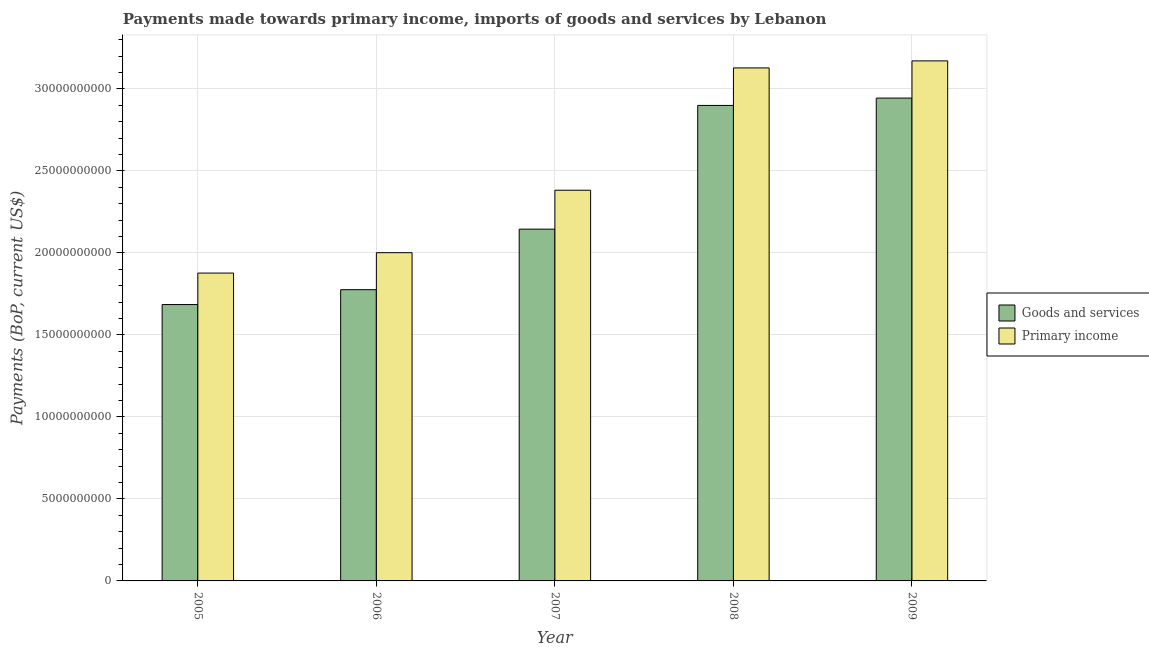Are the number of bars on each tick of the X-axis equal?
Give a very brief answer. Yes. How many bars are there on the 4th tick from the left?
Your answer should be very brief. 2. How many bars are there on the 5th tick from the right?
Provide a short and direct response. 2. What is the payments made towards primary income in 2009?
Your response must be concise. 3.17e+1. Across all years, what is the maximum payments made towards primary income?
Your response must be concise. 3.17e+1. Across all years, what is the minimum payments made towards goods and services?
Your answer should be compact. 1.68e+1. In which year was the payments made towards goods and services maximum?
Give a very brief answer. 2009. What is the total payments made towards primary income in the graph?
Ensure brevity in your answer.  1.26e+11. What is the difference between the payments made towards goods and services in 2006 and that in 2009?
Provide a short and direct response. -1.17e+1. What is the difference between the payments made towards primary income in 2009 and the payments made towards goods and services in 2008?
Provide a succinct answer. 4.30e+08. What is the average payments made towards primary income per year?
Keep it short and to the point. 2.51e+1. In the year 2005, what is the difference between the payments made towards primary income and payments made towards goods and services?
Give a very brief answer. 0. In how many years, is the payments made towards primary income greater than 6000000000 US$?
Offer a terse response. 5. What is the ratio of the payments made towards primary income in 2005 to that in 2007?
Provide a succinct answer. 0.79. Is the difference between the payments made towards goods and services in 2006 and 2009 greater than the difference between the payments made towards primary income in 2006 and 2009?
Keep it short and to the point. No. What is the difference between the highest and the second highest payments made towards goods and services?
Your response must be concise. 4.48e+08. What is the difference between the highest and the lowest payments made towards primary income?
Keep it short and to the point. 1.29e+1. In how many years, is the payments made towards primary income greater than the average payments made towards primary income taken over all years?
Your answer should be compact. 2. What does the 2nd bar from the left in 2005 represents?
Provide a succinct answer. Primary income. What does the 1st bar from the right in 2007 represents?
Give a very brief answer. Primary income. How many bars are there?
Give a very brief answer. 10. How many years are there in the graph?
Provide a short and direct response. 5. Are the values on the major ticks of Y-axis written in scientific E-notation?
Offer a very short reply. No. Does the graph contain any zero values?
Keep it short and to the point. No. Does the graph contain grids?
Make the answer very short. Yes. Where does the legend appear in the graph?
Give a very brief answer. Center right. What is the title of the graph?
Offer a very short reply. Payments made towards primary income, imports of goods and services by Lebanon. What is the label or title of the Y-axis?
Ensure brevity in your answer.  Payments (BoP, current US$). What is the Payments (BoP, current US$) in Goods and services in 2005?
Ensure brevity in your answer.  1.68e+1. What is the Payments (BoP, current US$) of Primary income in 2005?
Keep it short and to the point. 1.88e+1. What is the Payments (BoP, current US$) in Goods and services in 2006?
Offer a very short reply. 1.78e+1. What is the Payments (BoP, current US$) in Primary income in 2006?
Keep it short and to the point. 2.00e+1. What is the Payments (BoP, current US$) of Goods and services in 2007?
Ensure brevity in your answer.  2.14e+1. What is the Payments (BoP, current US$) in Primary income in 2007?
Your response must be concise. 2.38e+1. What is the Payments (BoP, current US$) of Goods and services in 2008?
Your response must be concise. 2.90e+1. What is the Payments (BoP, current US$) of Primary income in 2008?
Offer a very short reply. 3.13e+1. What is the Payments (BoP, current US$) in Goods and services in 2009?
Keep it short and to the point. 2.94e+1. What is the Payments (BoP, current US$) of Primary income in 2009?
Provide a succinct answer. 3.17e+1. Across all years, what is the maximum Payments (BoP, current US$) in Goods and services?
Your answer should be compact. 2.94e+1. Across all years, what is the maximum Payments (BoP, current US$) of Primary income?
Provide a succinct answer. 3.17e+1. Across all years, what is the minimum Payments (BoP, current US$) of Goods and services?
Offer a very short reply. 1.68e+1. Across all years, what is the minimum Payments (BoP, current US$) of Primary income?
Provide a short and direct response. 1.88e+1. What is the total Payments (BoP, current US$) in Goods and services in the graph?
Provide a succinct answer. 1.14e+11. What is the total Payments (BoP, current US$) of Primary income in the graph?
Keep it short and to the point. 1.26e+11. What is the difference between the Payments (BoP, current US$) of Goods and services in 2005 and that in 2006?
Give a very brief answer. -9.06e+08. What is the difference between the Payments (BoP, current US$) in Primary income in 2005 and that in 2006?
Keep it short and to the point. -1.24e+09. What is the difference between the Payments (BoP, current US$) of Goods and services in 2005 and that in 2007?
Make the answer very short. -4.60e+09. What is the difference between the Payments (BoP, current US$) in Primary income in 2005 and that in 2007?
Keep it short and to the point. -5.05e+09. What is the difference between the Payments (BoP, current US$) of Goods and services in 2005 and that in 2008?
Make the answer very short. -1.21e+1. What is the difference between the Payments (BoP, current US$) of Primary income in 2005 and that in 2008?
Make the answer very short. -1.25e+1. What is the difference between the Payments (BoP, current US$) in Goods and services in 2005 and that in 2009?
Your answer should be very brief. -1.26e+1. What is the difference between the Payments (BoP, current US$) in Primary income in 2005 and that in 2009?
Make the answer very short. -1.29e+1. What is the difference between the Payments (BoP, current US$) of Goods and services in 2006 and that in 2007?
Your answer should be compact. -3.69e+09. What is the difference between the Payments (BoP, current US$) of Primary income in 2006 and that in 2007?
Provide a short and direct response. -3.81e+09. What is the difference between the Payments (BoP, current US$) in Goods and services in 2006 and that in 2008?
Provide a short and direct response. -1.12e+1. What is the difference between the Payments (BoP, current US$) of Primary income in 2006 and that in 2008?
Make the answer very short. -1.13e+1. What is the difference between the Payments (BoP, current US$) in Goods and services in 2006 and that in 2009?
Provide a short and direct response. -1.17e+1. What is the difference between the Payments (BoP, current US$) of Primary income in 2006 and that in 2009?
Your answer should be compact. -1.17e+1. What is the difference between the Payments (BoP, current US$) of Goods and services in 2007 and that in 2008?
Make the answer very short. -7.54e+09. What is the difference between the Payments (BoP, current US$) in Primary income in 2007 and that in 2008?
Give a very brief answer. -7.46e+09. What is the difference between the Payments (BoP, current US$) of Goods and services in 2007 and that in 2009?
Provide a short and direct response. -7.99e+09. What is the difference between the Payments (BoP, current US$) of Primary income in 2007 and that in 2009?
Provide a short and direct response. -7.89e+09. What is the difference between the Payments (BoP, current US$) in Goods and services in 2008 and that in 2009?
Provide a succinct answer. -4.48e+08. What is the difference between the Payments (BoP, current US$) of Primary income in 2008 and that in 2009?
Your answer should be compact. -4.30e+08. What is the difference between the Payments (BoP, current US$) of Goods and services in 2005 and the Payments (BoP, current US$) of Primary income in 2006?
Keep it short and to the point. -3.16e+09. What is the difference between the Payments (BoP, current US$) in Goods and services in 2005 and the Payments (BoP, current US$) in Primary income in 2007?
Your answer should be compact. -6.97e+09. What is the difference between the Payments (BoP, current US$) in Goods and services in 2005 and the Payments (BoP, current US$) in Primary income in 2008?
Give a very brief answer. -1.44e+1. What is the difference between the Payments (BoP, current US$) of Goods and services in 2005 and the Payments (BoP, current US$) of Primary income in 2009?
Provide a short and direct response. -1.49e+1. What is the difference between the Payments (BoP, current US$) of Goods and services in 2006 and the Payments (BoP, current US$) of Primary income in 2007?
Your answer should be compact. -6.06e+09. What is the difference between the Payments (BoP, current US$) of Goods and services in 2006 and the Payments (BoP, current US$) of Primary income in 2008?
Give a very brief answer. -1.35e+1. What is the difference between the Payments (BoP, current US$) of Goods and services in 2006 and the Payments (BoP, current US$) of Primary income in 2009?
Offer a very short reply. -1.39e+1. What is the difference between the Payments (BoP, current US$) in Goods and services in 2007 and the Payments (BoP, current US$) in Primary income in 2008?
Keep it short and to the point. -9.83e+09. What is the difference between the Payments (BoP, current US$) of Goods and services in 2007 and the Payments (BoP, current US$) of Primary income in 2009?
Your answer should be very brief. -1.03e+1. What is the difference between the Payments (BoP, current US$) in Goods and services in 2008 and the Payments (BoP, current US$) in Primary income in 2009?
Offer a very short reply. -2.72e+09. What is the average Payments (BoP, current US$) in Goods and services per year?
Give a very brief answer. 2.29e+1. What is the average Payments (BoP, current US$) of Primary income per year?
Your answer should be very brief. 2.51e+1. In the year 2005, what is the difference between the Payments (BoP, current US$) in Goods and services and Payments (BoP, current US$) in Primary income?
Give a very brief answer. -1.92e+09. In the year 2006, what is the difference between the Payments (BoP, current US$) in Goods and services and Payments (BoP, current US$) in Primary income?
Your response must be concise. -2.26e+09. In the year 2007, what is the difference between the Payments (BoP, current US$) in Goods and services and Payments (BoP, current US$) in Primary income?
Your answer should be very brief. -2.37e+09. In the year 2008, what is the difference between the Payments (BoP, current US$) in Goods and services and Payments (BoP, current US$) in Primary income?
Offer a terse response. -2.29e+09. In the year 2009, what is the difference between the Payments (BoP, current US$) of Goods and services and Payments (BoP, current US$) of Primary income?
Your answer should be compact. -2.27e+09. What is the ratio of the Payments (BoP, current US$) of Goods and services in 2005 to that in 2006?
Ensure brevity in your answer.  0.95. What is the ratio of the Payments (BoP, current US$) in Primary income in 2005 to that in 2006?
Keep it short and to the point. 0.94. What is the ratio of the Payments (BoP, current US$) of Goods and services in 2005 to that in 2007?
Offer a very short reply. 0.79. What is the ratio of the Payments (BoP, current US$) of Primary income in 2005 to that in 2007?
Your answer should be compact. 0.79. What is the ratio of the Payments (BoP, current US$) of Goods and services in 2005 to that in 2008?
Your answer should be very brief. 0.58. What is the ratio of the Payments (BoP, current US$) in Primary income in 2005 to that in 2008?
Make the answer very short. 0.6. What is the ratio of the Payments (BoP, current US$) of Goods and services in 2005 to that in 2009?
Offer a very short reply. 0.57. What is the ratio of the Payments (BoP, current US$) of Primary income in 2005 to that in 2009?
Provide a succinct answer. 0.59. What is the ratio of the Payments (BoP, current US$) in Goods and services in 2006 to that in 2007?
Give a very brief answer. 0.83. What is the ratio of the Payments (BoP, current US$) in Primary income in 2006 to that in 2007?
Keep it short and to the point. 0.84. What is the ratio of the Payments (BoP, current US$) in Goods and services in 2006 to that in 2008?
Your answer should be compact. 0.61. What is the ratio of the Payments (BoP, current US$) in Primary income in 2006 to that in 2008?
Offer a very short reply. 0.64. What is the ratio of the Payments (BoP, current US$) in Goods and services in 2006 to that in 2009?
Keep it short and to the point. 0.6. What is the ratio of the Payments (BoP, current US$) of Primary income in 2006 to that in 2009?
Make the answer very short. 0.63. What is the ratio of the Payments (BoP, current US$) in Goods and services in 2007 to that in 2008?
Keep it short and to the point. 0.74. What is the ratio of the Payments (BoP, current US$) of Primary income in 2007 to that in 2008?
Ensure brevity in your answer.  0.76. What is the ratio of the Payments (BoP, current US$) in Goods and services in 2007 to that in 2009?
Your response must be concise. 0.73. What is the ratio of the Payments (BoP, current US$) of Primary income in 2007 to that in 2009?
Offer a very short reply. 0.75. What is the ratio of the Payments (BoP, current US$) of Primary income in 2008 to that in 2009?
Keep it short and to the point. 0.99. What is the difference between the highest and the second highest Payments (BoP, current US$) of Goods and services?
Provide a short and direct response. 4.48e+08. What is the difference between the highest and the second highest Payments (BoP, current US$) in Primary income?
Keep it short and to the point. 4.30e+08. What is the difference between the highest and the lowest Payments (BoP, current US$) of Goods and services?
Your answer should be very brief. 1.26e+1. What is the difference between the highest and the lowest Payments (BoP, current US$) in Primary income?
Provide a succinct answer. 1.29e+1. 